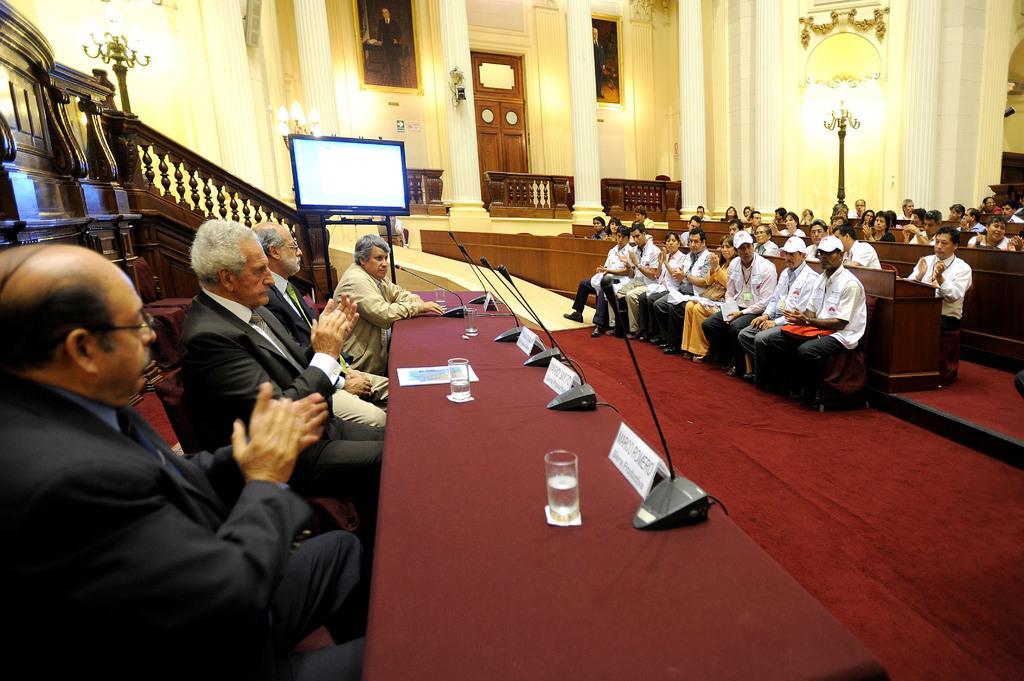How would you summarize this image in a sentence or two? This picture describes about group of people, they are seated, and few people wore caps, in the middle of the image we can see a screen, few glasses, microphones, name boards and other things on the table, in the background we can find few lights. 